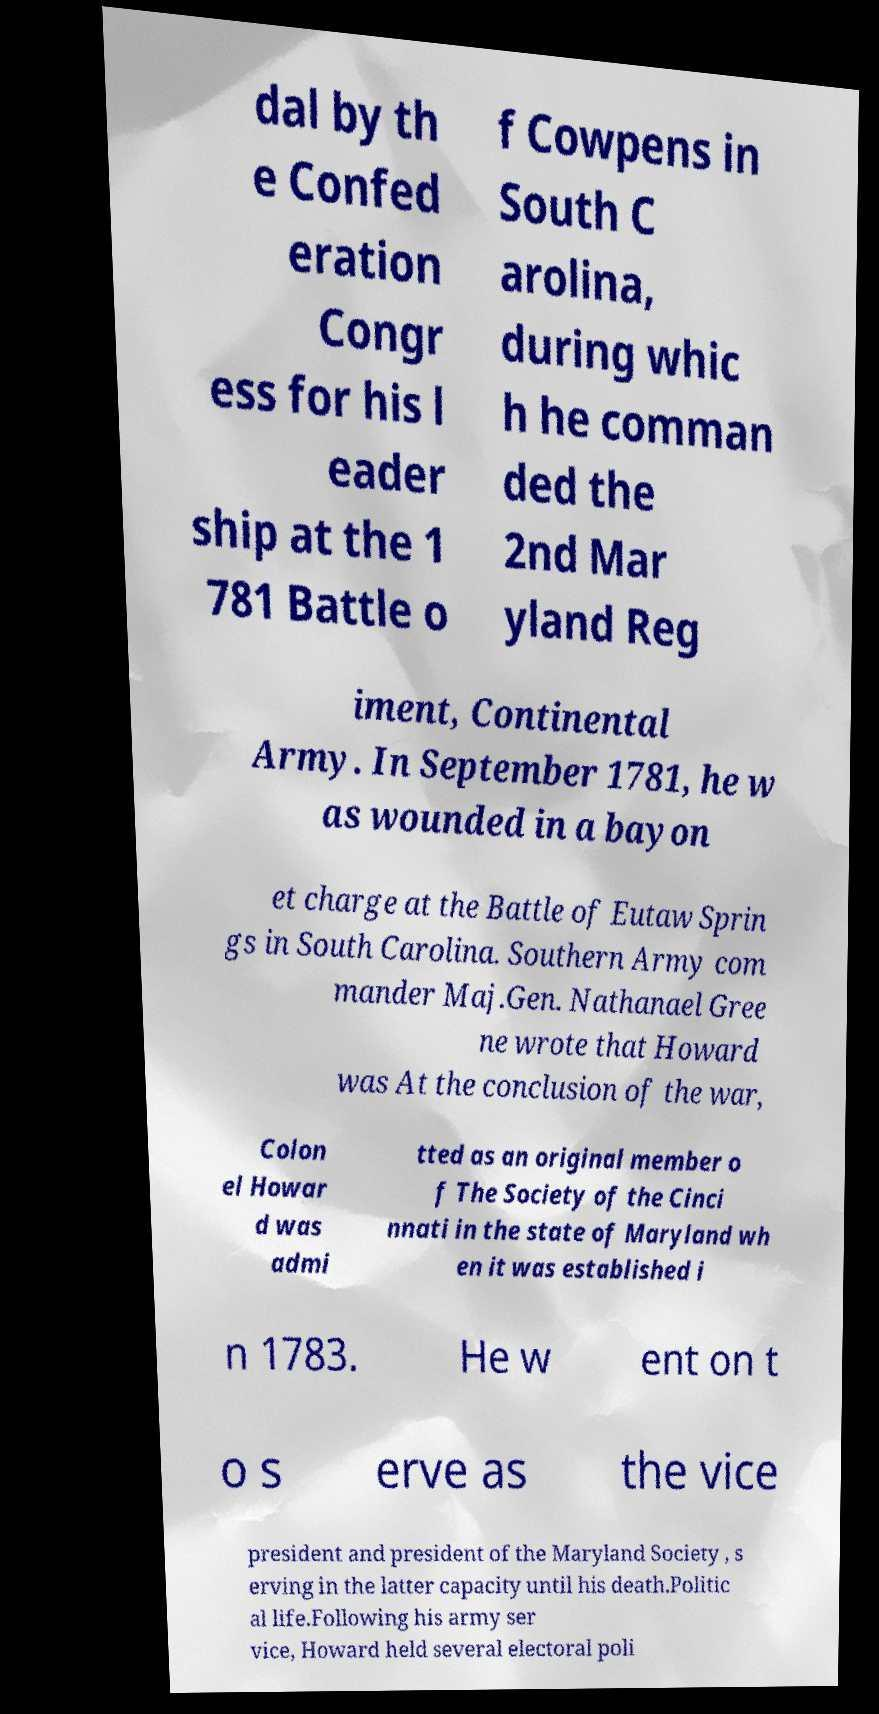Please read and relay the text visible in this image. What does it say? dal by th e Confed eration Congr ess for his l eader ship at the 1 781 Battle o f Cowpens in South C arolina, during whic h he comman ded the 2nd Mar yland Reg iment, Continental Army. In September 1781, he w as wounded in a bayon et charge at the Battle of Eutaw Sprin gs in South Carolina. Southern Army com mander Maj.Gen. Nathanael Gree ne wrote that Howard was At the conclusion of the war, Colon el Howar d was admi tted as an original member o f The Society of the Cinci nnati in the state of Maryland wh en it was established i n 1783. He w ent on t o s erve as the vice president and president of the Maryland Society , s erving in the latter capacity until his death.Politic al life.Following his army ser vice, Howard held several electoral poli 